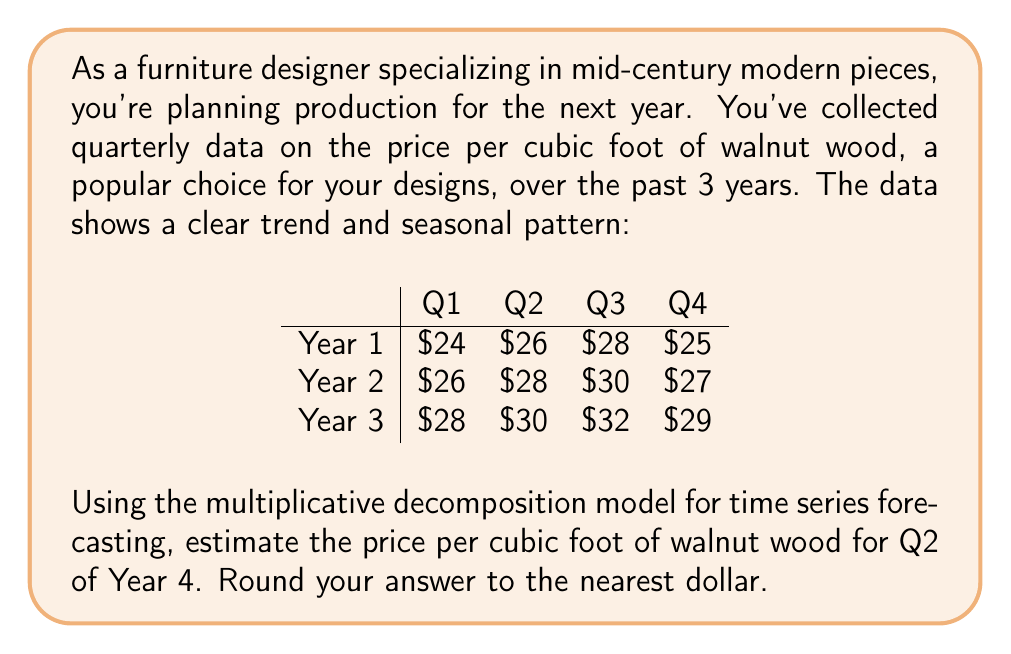What is the answer to this math problem? To forecast the price using the multiplicative decomposition model, we'll follow these steps:

1) First, let's identify the components:
   - Trend (T)
   - Seasonal factor (S)
   - Cyclical factor (C) - we'll assume this is negligible for simplicity
   - Irregular factor (I) - we'll also assume this is negligible

2) Calculate the trend:
   We can use a simple linear regression. Let's number our quarters from 1 to 12.
   
   $$ T_t = a + bt $$
   
   Where $a$ is the y-intercept and $b$ is the slope.
   
   Using a calculator or spreadsheet, we get:
   $a = 23.5$ and $b = 0.5$

   So our trend equation is: $T_t = 23.5 + 0.5t$

3) Calculate seasonal factors:
   Divide each actual value by its corresponding trend value:
   
   $$ S_i = \frac{\text{Actual}}{\text{Trend}} $$
   
   Then average these for each quarter:
   
   Q1: $(24/24 + 26/26.5 + 28/29) / 3 = 0.9778$
   Q2: $(26/24.5 + 28/27 + 30/29.5) / 3 = 1.0556$
   Q3: $(28/25 + 30/27.5 + 32/30) / 3 = 1.1111$
   Q4: $(25/25.5 + 27/28 + 29/30.5) / 3 = 0.9556$

4) For Q2 of Year 4 (t = 14):
   Trend: $T_{14} = 23.5 + 0.5(14) = 30.5$
   Seasonal factor for Q2: 1.0556

5) Forecast:
   $$ \text{Forecast} = T_{14} * S_{Q2} = 30.5 * 1.0556 = 32.1958 $$

6) Rounding to the nearest dollar: $32
Answer: $32 